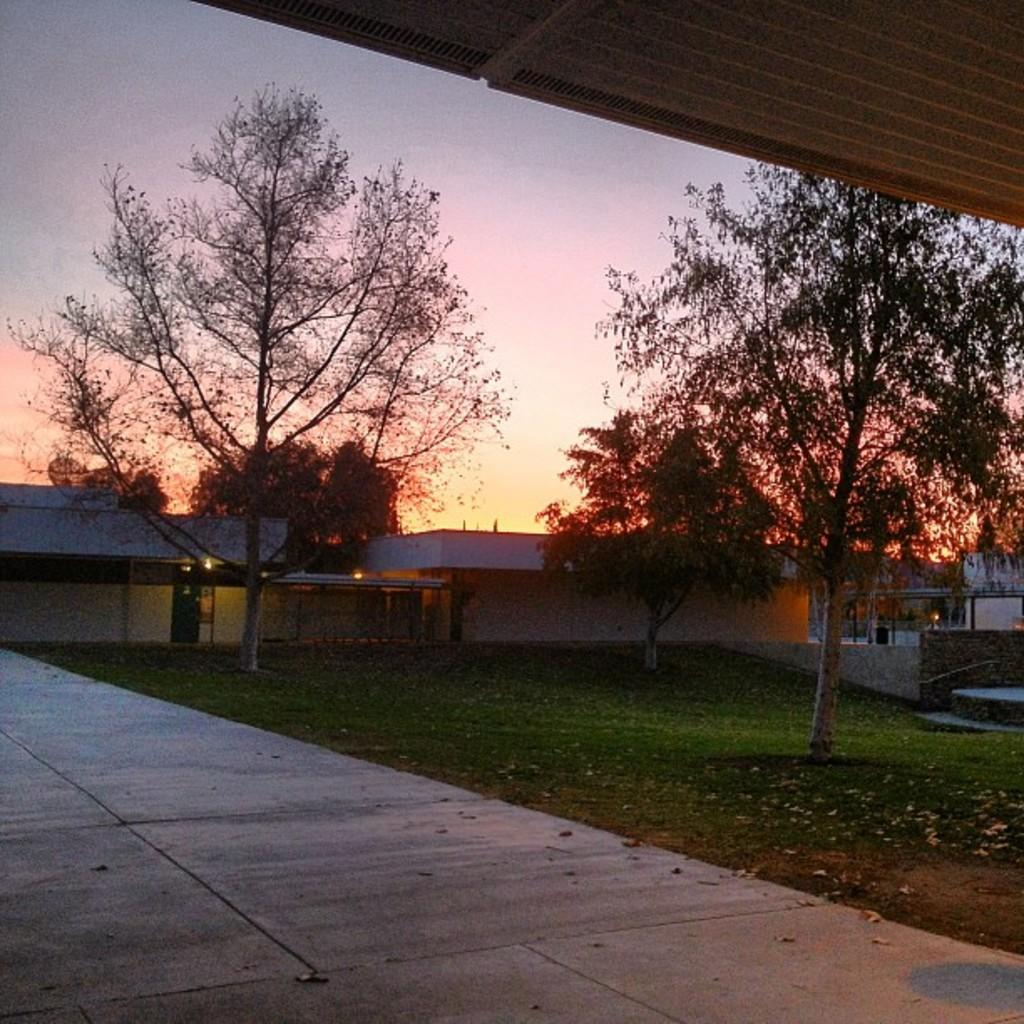What type of structures can be seen in the image? There are buildings in the image. What natural elements are present in the image? There are trees and grass in the image. What is visible at the top of the image? The sky is visible at the top of the image. What type of surface is at the bottom of the image? There is a pavement at the bottom of the image. What additional detail can be observed in the image? Dried leaves are present in the image. Can you tell me how many pies are being marked on the pavement in the image? There are no pies present in the image, and no marking activity is taking place on the pavement. 